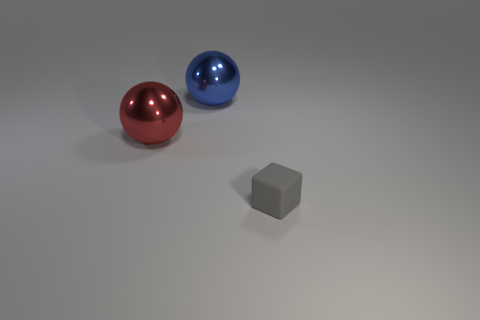Imagine the red sphere is a character; what personality traits might it have based on its appearance? If the red sphere were a character, its vibrant red hue and noticeable size could imply boldness, confidence, and a strong presence. Its smooth and shiny surface might suggest a polished, sophisticated personality. 